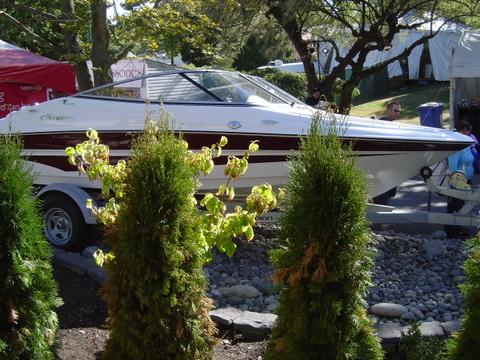What color is the trash can?
Keep it brief. Blue. What type of trees are closest to the camera?
Concise answer only. Pine. Is this a sailing boat?
Write a very short answer. No. 